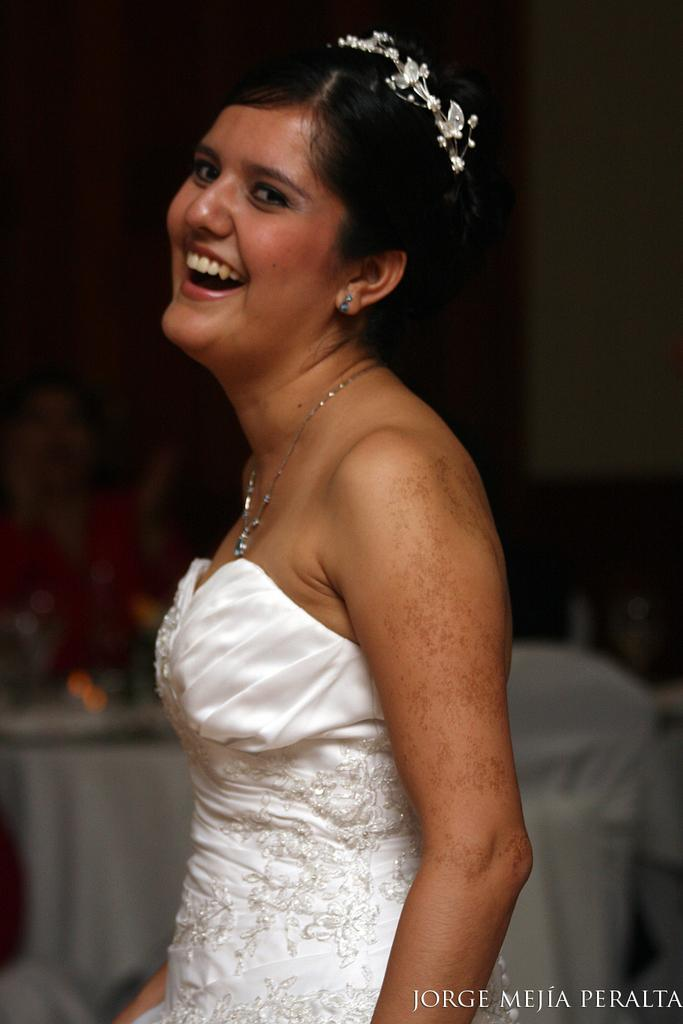Who is present in the image? There is a woman in the image. What is the woman's expression? The woman is smiling. What can be seen in the background of the image? There are objects in the background of the image. How would you describe the lighting in the image? The image has a dark setting. What type of cherry is the woman holding in the image? There is no cherry present in the image. Is the woman's mom in the image as well? The provided facts do not mention the presence of the woman's mom in the image. --- Facts: 1. There is a car in the image. 2. The car is red. 3. The car has four wheels. 4. There are people in the car. 5. The car is parked on the street. Absurd Topics: fish, mountain, dance Conversation: What is the main subject of the image? The main subject of the image is a car. What color is the car? The car is red. How many wheels does the car have? The car has four wheels. Are there any passengers in the car? Yes, there are people in the car. Where is the car located in the image? The car is parked on the street. Reasoning: Let's think step by step in order to produce the conversation. We start by identifying the main subject in the image, which is the car. Then, we describe the car's color and the number of wheels it has. Next, we mention the presence of passengers in the car. Finally, we address the car's location, which is parked on the street. Absurd Question/Answer: Can you see any fish swimming near the car in the image? No, there are no fish visible in the image. Is the car parked at the base of a mountain in the image? The provided facts do not mention the presence of a mountain in the image. 